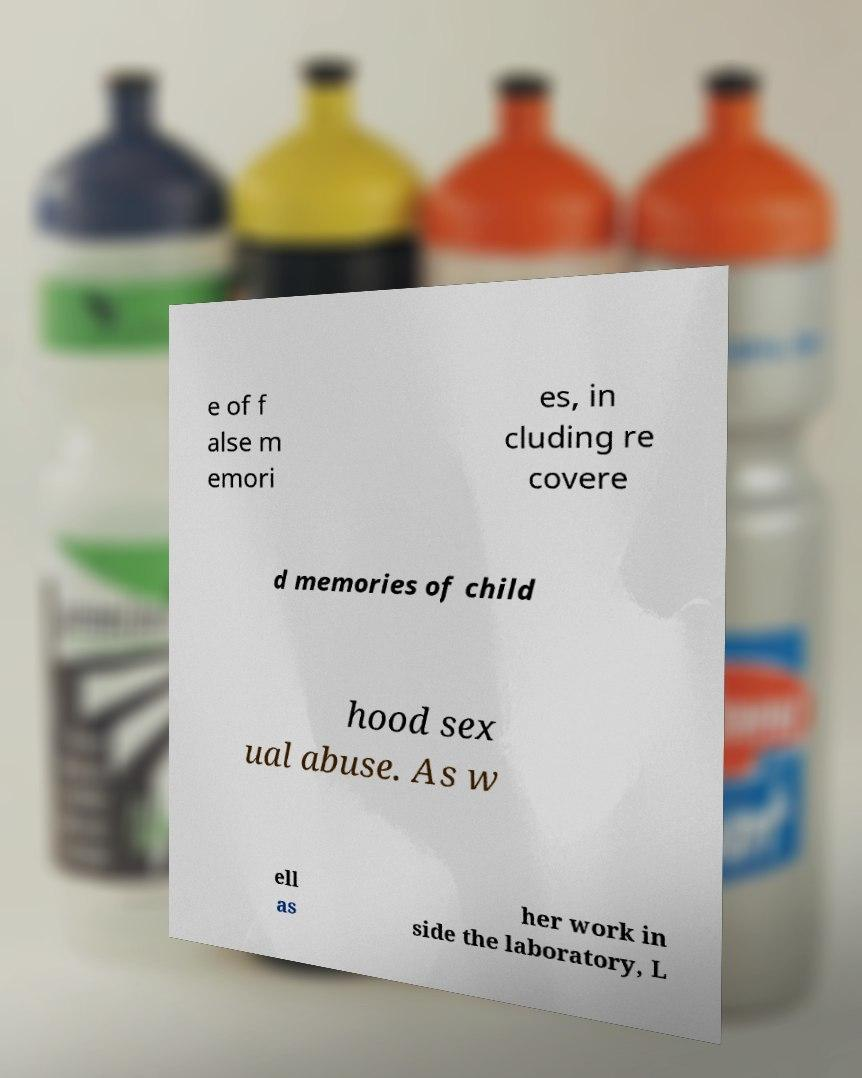Could you assist in decoding the text presented in this image and type it out clearly? e of f alse m emori es, in cluding re covere d memories of child hood sex ual abuse. As w ell as her work in side the laboratory, L 